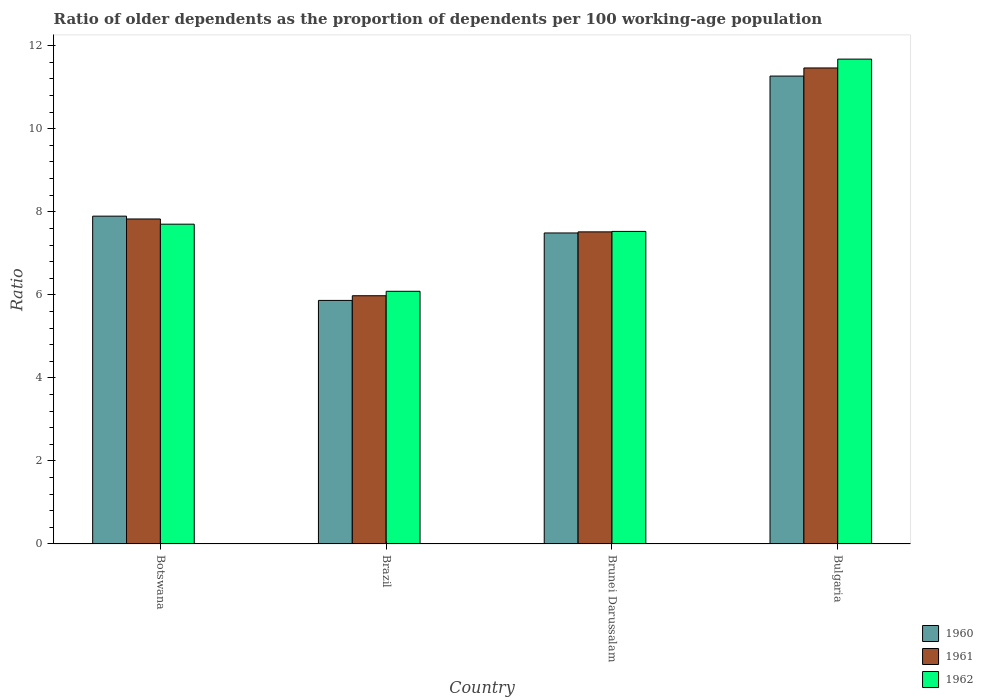How many different coloured bars are there?
Make the answer very short. 3. How many groups of bars are there?
Provide a succinct answer. 4. Are the number of bars on each tick of the X-axis equal?
Your answer should be compact. Yes. How many bars are there on the 3rd tick from the right?
Give a very brief answer. 3. What is the label of the 3rd group of bars from the left?
Give a very brief answer. Brunei Darussalam. In how many cases, is the number of bars for a given country not equal to the number of legend labels?
Provide a succinct answer. 0. What is the age dependency ratio(old) in 1961 in Brunei Darussalam?
Offer a terse response. 7.52. Across all countries, what is the maximum age dependency ratio(old) in 1960?
Keep it short and to the point. 11.27. Across all countries, what is the minimum age dependency ratio(old) in 1960?
Provide a short and direct response. 5.87. In which country was the age dependency ratio(old) in 1961 minimum?
Your response must be concise. Brazil. What is the total age dependency ratio(old) in 1961 in the graph?
Your answer should be compact. 32.79. What is the difference between the age dependency ratio(old) in 1960 in Brazil and that in Brunei Darussalam?
Provide a succinct answer. -1.62. What is the difference between the age dependency ratio(old) in 1961 in Brazil and the age dependency ratio(old) in 1960 in Botswana?
Make the answer very short. -1.92. What is the average age dependency ratio(old) in 1960 per country?
Your answer should be very brief. 8.13. What is the difference between the age dependency ratio(old) of/in 1961 and age dependency ratio(old) of/in 1960 in Brazil?
Offer a terse response. 0.11. In how many countries, is the age dependency ratio(old) in 1961 greater than 4.4?
Offer a very short reply. 4. What is the ratio of the age dependency ratio(old) in 1960 in Brazil to that in Brunei Darussalam?
Your response must be concise. 0.78. Is the age dependency ratio(old) in 1962 in Brunei Darussalam less than that in Bulgaria?
Provide a succinct answer. Yes. Is the difference between the age dependency ratio(old) in 1961 in Botswana and Brazil greater than the difference between the age dependency ratio(old) in 1960 in Botswana and Brazil?
Provide a short and direct response. No. What is the difference between the highest and the second highest age dependency ratio(old) in 1962?
Your response must be concise. 4.15. What is the difference between the highest and the lowest age dependency ratio(old) in 1960?
Offer a very short reply. 5.4. Is the sum of the age dependency ratio(old) in 1962 in Brunei Darussalam and Bulgaria greater than the maximum age dependency ratio(old) in 1960 across all countries?
Ensure brevity in your answer.  Yes. What does the 1st bar from the left in Brazil represents?
Ensure brevity in your answer.  1960. How many bars are there?
Make the answer very short. 12. Are all the bars in the graph horizontal?
Keep it short and to the point. No. How many countries are there in the graph?
Provide a short and direct response. 4. What is the difference between two consecutive major ticks on the Y-axis?
Provide a succinct answer. 2. Does the graph contain grids?
Give a very brief answer. No. Where does the legend appear in the graph?
Keep it short and to the point. Bottom right. How are the legend labels stacked?
Your response must be concise. Vertical. What is the title of the graph?
Your answer should be very brief. Ratio of older dependents as the proportion of dependents per 100 working-age population. What is the label or title of the Y-axis?
Provide a short and direct response. Ratio. What is the Ratio of 1960 in Botswana?
Offer a very short reply. 7.9. What is the Ratio in 1961 in Botswana?
Provide a succinct answer. 7.83. What is the Ratio of 1962 in Botswana?
Offer a terse response. 7.7. What is the Ratio of 1960 in Brazil?
Ensure brevity in your answer.  5.87. What is the Ratio in 1961 in Brazil?
Offer a terse response. 5.98. What is the Ratio of 1962 in Brazil?
Make the answer very short. 6.09. What is the Ratio in 1960 in Brunei Darussalam?
Keep it short and to the point. 7.49. What is the Ratio in 1961 in Brunei Darussalam?
Your response must be concise. 7.52. What is the Ratio in 1962 in Brunei Darussalam?
Ensure brevity in your answer.  7.53. What is the Ratio of 1960 in Bulgaria?
Offer a very short reply. 11.27. What is the Ratio of 1961 in Bulgaria?
Offer a very short reply. 11.46. What is the Ratio in 1962 in Bulgaria?
Your response must be concise. 11.68. Across all countries, what is the maximum Ratio in 1960?
Offer a terse response. 11.27. Across all countries, what is the maximum Ratio in 1961?
Offer a very short reply. 11.46. Across all countries, what is the maximum Ratio in 1962?
Offer a very short reply. 11.68. Across all countries, what is the minimum Ratio in 1960?
Provide a short and direct response. 5.87. Across all countries, what is the minimum Ratio of 1961?
Keep it short and to the point. 5.98. Across all countries, what is the minimum Ratio in 1962?
Offer a terse response. 6.09. What is the total Ratio of 1960 in the graph?
Provide a short and direct response. 32.52. What is the total Ratio in 1961 in the graph?
Offer a very short reply. 32.79. What is the total Ratio of 1962 in the graph?
Your answer should be compact. 32.99. What is the difference between the Ratio of 1960 in Botswana and that in Brazil?
Offer a very short reply. 2.03. What is the difference between the Ratio in 1961 in Botswana and that in Brazil?
Your answer should be very brief. 1.85. What is the difference between the Ratio in 1962 in Botswana and that in Brazil?
Your response must be concise. 1.62. What is the difference between the Ratio in 1960 in Botswana and that in Brunei Darussalam?
Your answer should be compact. 0.41. What is the difference between the Ratio of 1961 in Botswana and that in Brunei Darussalam?
Ensure brevity in your answer.  0.31. What is the difference between the Ratio in 1962 in Botswana and that in Brunei Darussalam?
Offer a very short reply. 0.17. What is the difference between the Ratio of 1960 in Botswana and that in Bulgaria?
Give a very brief answer. -3.37. What is the difference between the Ratio in 1961 in Botswana and that in Bulgaria?
Make the answer very short. -3.64. What is the difference between the Ratio in 1962 in Botswana and that in Bulgaria?
Offer a terse response. -3.98. What is the difference between the Ratio in 1960 in Brazil and that in Brunei Darussalam?
Provide a short and direct response. -1.62. What is the difference between the Ratio of 1961 in Brazil and that in Brunei Darussalam?
Keep it short and to the point. -1.54. What is the difference between the Ratio of 1962 in Brazil and that in Brunei Darussalam?
Ensure brevity in your answer.  -1.44. What is the difference between the Ratio of 1960 in Brazil and that in Bulgaria?
Offer a terse response. -5.4. What is the difference between the Ratio in 1961 in Brazil and that in Bulgaria?
Your response must be concise. -5.49. What is the difference between the Ratio in 1962 in Brazil and that in Bulgaria?
Make the answer very short. -5.59. What is the difference between the Ratio in 1960 in Brunei Darussalam and that in Bulgaria?
Your answer should be compact. -3.78. What is the difference between the Ratio of 1961 in Brunei Darussalam and that in Bulgaria?
Keep it short and to the point. -3.95. What is the difference between the Ratio in 1962 in Brunei Darussalam and that in Bulgaria?
Give a very brief answer. -4.15. What is the difference between the Ratio in 1960 in Botswana and the Ratio in 1961 in Brazil?
Give a very brief answer. 1.92. What is the difference between the Ratio of 1960 in Botswana and the Ratio of 1962 in Brazil?
Give a very brief answer. 1.81. What is the difference between the Ratio of 1961 in Botswana and the Ratio of 1962 in Brazil?
Your answer should be very brief. 1.74. What is the difference between the Ratio in 1960 in Botswana and the Ratio in 1961 in Brunei Darussalam?
Offer a terse response. 0.38. What is the difference between the Ratio in 1960 in Botswana and the Ratio in 1962 in Brunei Darussalam?
Your answer should be compact. 0.37. What is the difference between the Ratio in 1961 in Botswana and the Ratio in 1962 in Brunei Darussalam?
Offer a terse response. 0.3. What is the difference between the Ratio of 1960 in Botswana and the Ratio of 1961 in Bulgaria?
Your answer should be very brief. -3.57. What is the difference between the Ratio in 1960 in Botswana and the Ratio in 1962 in Bulgaria?
Ensure brevity in your answer.  -3.78. What is the difference between the Ratio in 1961 in Botswana and the Ratio in 1962 in Bulgaria?
Keep it short and to the point. -3.85. What is the difference between the Ratio in 1960 in Brazil and the Ratio in 1961 in Brunei Darussalam?
Provide a short and direct response. -1.65. What is the difference between the Ratio in 1960 in Brazil and the Ratio in 1962 in Brunei Darussalam?
Your response must be concise. -1.66. What is the difference between the Ratio in 1961 in Brazil and the Ratio in 1962 in Brunei Darussalam?
Keep it short and to the point. -1.55. What is the difference between the Ratio of 1960 in Brazil and the Ratio of 1961 in Bulgaria?
Provide a short and direct response. -5.6. What is the difference between the Ratio in 1960 in Brazil and the Ratio in 1962 in Bulgaria?
Offer a very short reply. -5.81. What is the difference between the Ratio in 1961 in Brazil and the Ratio in 1962 in Bulgaria?
Your response must be concise. -5.7. What is the difference between the Ratio of 1960 in Brunei Darussalam and the Ratio of 1961 in Bulgaria?
Offer a very short reply. -3.97. What is the difference between the Ratio of 1960 in Brunei Darussalam and the Ratio of 1962 in Bulgaria?
Give a very brief answer. -4.19. What is the difference between the Ratio of 1961 in Brunei Darussalam and the Ratio of 1962 in Bulgaria?
Offer a very short reply. -4.16. What is the average Ratio in 1960 per country?
Your answer should be very brief. 8.13. What is the average Ratio of 1961 per country?
Your response must be concise. 8.2. What is the average Ratio in 1962 per country?
Offer a terse response. 8.25. What is the difference between the Ratio in 1960 and Ratio in 1961 in Botswana?
Your answer should be very brief. 0.07. What is the difference between the Ratio in 1960 and Ratio in 1962 in Botswana?
Provide a short and direct response. 0.19. What is the difference between the Ratio in 1961 and Ratio in 1962 in Botswana?
Your answer should be very brief. 0.13. What is the difference between the Ratio of 1960 and Ratio of 1961 in Brazil?
Ensure brevity in your answer.  -0.11. What is the difference between the Ratio of 1960 and Ratio of 1962 in Brazil?
Keep it short and to the point. -0.22. What is the difference between the Ratio in 1961 and Ratio in 1962 in Brazil?
Make the answer very short. -0.11. What is the difference between the Ratio of 1960 and Ratio of 1961 in Brunei Darussalam?
Give a very brief answer. -0.03. What is the difference between the Ratio in 1960 and Ratio in 1962 in Brunei Darussalam?
Provide a short and direct response. -0.04. What is the difference between the Ratio in 1961 and Ratio in 1962 in Brunei Darussalam?
Keep it short and to the point. -0.01. What is the difference between the Ratio of 1960 and Ratio of 1961 in Bulgaria?
Keep it short and to the point. -0.2. What is the difference between the Ratio in 1960 and Ratio in 1962 in Bulgaria?
Offer a terse response. -0.41. What is the difference between the Ratio of 1961 and Ratio of 1962 in Bulgaria?
Your answer should be very brief. -0.21. What is the ratio of the Ratio of 1960 in Botswana to that in Brazil?
Make the answer very short. 1.35. What is the ratio of the Ratio of 1961 in Botswana to that in Brazil?
Offer a terse response. 1.31. What is the ratio of the Ratio of 1962 in Botswana to that in Brazil?
Provide a short and direct response. 1.27. What is the ratio of the Ratio of 1960 in Botswana to that in Brunei Darussalam?
Give a very brief answer. 1.05. What is the ratio of the Ratio in 1961 in Botswana to that in Brunei Darussalam?
Your response must be concise. 1.04. What is the ratio of the Ratio in 1962 in Botswana to that in Brunei Darussalam?
Give a very brief answer. 1.02. What is the ratio of the Ratio in 1960 in Botswana to that in Bulgaria?
Offer a very short reply. 0.7. What is the ratio of the Ratio in 1961 in Botswana to that in Bulgaria?
Your response must be concise. 0.68. What is the ratio of the Ratio of 1962 in Botswana to that in Bulgaria?
Your answer should be compact. 0.66. What is the ratio of the Ratio of 1960 in Brazil to that in Brunei Darussalam?
Give a very brief answer. 0.78. What is the ratio of the Ratio of 1961 in Brazil to that in Brunei Darussalam?
Your response must be concise. 0.8. What is the ratio of the Ratio of 1962 in Brazil to that in Brunei Darussalam?
Keep it short and to the point. 0.81. What is the ratio of the Ratio of 1960 in Brazil to that in Bulgaria?
Ensure brevity in your answer.  0.52. What is the ratio of the Ratio in 1961 in Brazil to that in Bulgaria?
Your answer should be compact. 0.52. What is the ratio of the Ratio of 1962 in Brazil to that in Bulgaria?
Provide a succinct answer. 0.52. What is the ratio of the Ratio in 1960 in Brunei Darussalam to that in Bulgaria?
Your answer should be very brief. 0.66. What is the ratio of the Ratio in 1961 in Brunei Darussalam to that in Bulgaria?
Make the answer very short. 0.66. What is the ratio of the Ratio in 1962 in Brunei Darussalam to that in Bulgaria?
Your answer should be compact. 0.64. What is the difference between the highest and the second highest Ratio of 1960?
Give a very brief answer. 3.37. What is the difference between the highest and the second highest Ratio of 1961?
Give a very brief answer. 3.64. What is the difference between the highest and the second highest Ratio in 1962?
Offer a very short reply. 3.98. What is the difference between the highest and the lowest Ratio of 1960?
Your answer should be compact. 5.4. What is the difference between the highest and the lowest Ratio in 1961?
Your response must be concise. 5.49. What is the difference between the highest and the lowest Ratio in 1962?
Keep it short and to the point. 5.59. 